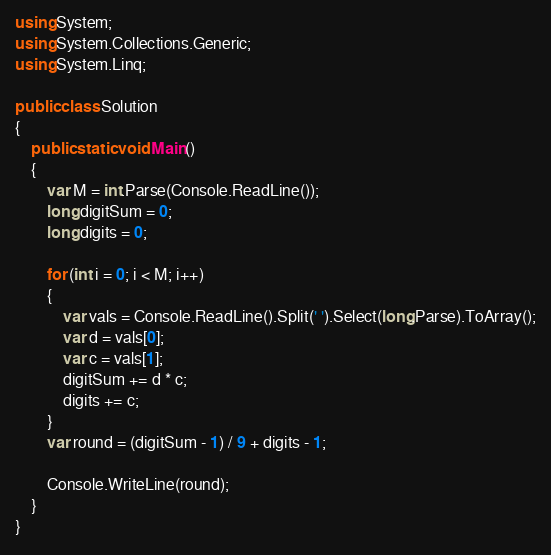Convert code to text. <code><loc_0><loc_0><loc_500><loc_500><_C#_>using System;
using System.Collections.Generic;
using System.Linq;

public class Solution
{
    public static void Main()
    {
        var M = int.Parse(Console.ReadLine());
        long digitSum = 0;
        long digits = 0;

        for (int i = 0; i < M; i++)
        {
            var vals = Console.ReadLine().Split(' ').Select(long.Parse).ToArray();
            var d = vals[0];
            var c = vals[1];
            digitSum += d * c;
            digits += c;
        }
        var round = (digitSum - 1) / 9 + digits - 1;

        Console.WriteLine(round);
    }
}</code> 